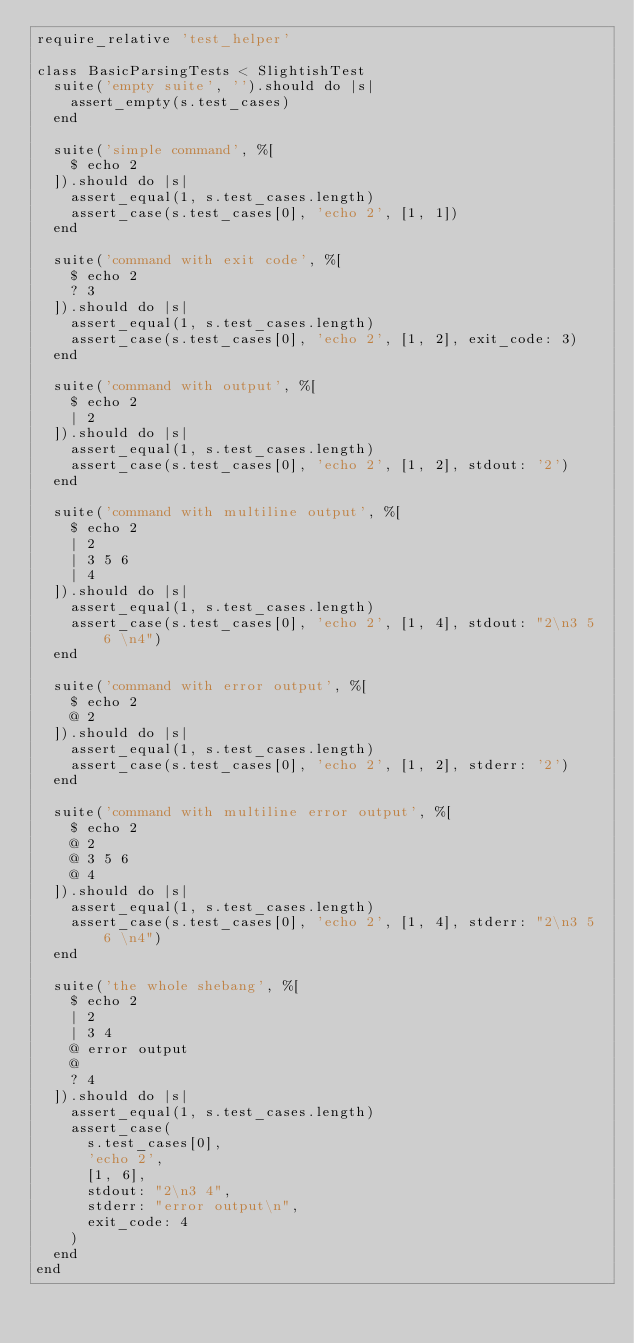<code> <loc_0><loc_0><loc_500><loc_500><_Ruby_>require_relative 'test_helper'

class BasicParsingTests < SlightishTest
  suite('empty suite', '').should do |s|
    assert_empty(s.test_cases)
  end

  suite('simple command', %[
    $ echo 2
  ]).should do |s|
    assert_equal(1, s.test_cases.length)
    assert_case(s.test_cases[0], 'echo 2', [1, 1])
  end

  suite('command with exit code', %[
    $ echo 2
    ? 3
  ]).should do |s|
    assert_equal(1, s.test_cases.length)
    assert_case(s.test_cases[0], 'echo 2', [1, 2], exit_code: 3)
  end

  suite('command with output', %[
    $ echo 2
    | 2
  ]).should do |s|
    assert_equal(1, s.test_cases.length)
    assert_case(s.test_cases[0], 'echo 2', [1, 2], stdout: '2')
  end

  suite('command with multiline output', %[
    $ echo 2
    | 2
    | 3 5 6 
    | 4
  ]).should do |s|
    assert_equal(1, s.test_cases.length)
    assert_case(s.test_cases[0], 'echo 2', [1, 4], stdout: "2\n3 5 6 \n4")
  end

  suite('command with error output', %[
    $ echo 2
    @ 2
  ]).should do |s|
    assert_equal(1, s.test_cases.length)
    assert_case(s.test_cases[0], 'echo 2', [1, 2], stderr: '2')
  end

  suite('command with multiline error output', %[
    $ echo 2
    @ 2
    @ 3 5 6 
    @ 4
  ]).should do |s|
    assert_equal(1, s.test_cases.length)
    assert_case(s.test_cases[0], 'echo 2', [1, 4], stderr: "2\n3 5 6 \n4")
  end

  suite('the whole shebang', %[
    $ echo 2
    | 2
    | 3 4
    @ error output
    @ 
    ? 4
  ]).should do |s|
    assert_equal(1, s.test_cases.length)
    assert_case(
      s.test_cases[0],
      'echo 2',
      [1, 6],
      stdout: "2\n3 4",
      stderr: "error output\n",
      exit_code: 4
    )
  end
end
</code> 